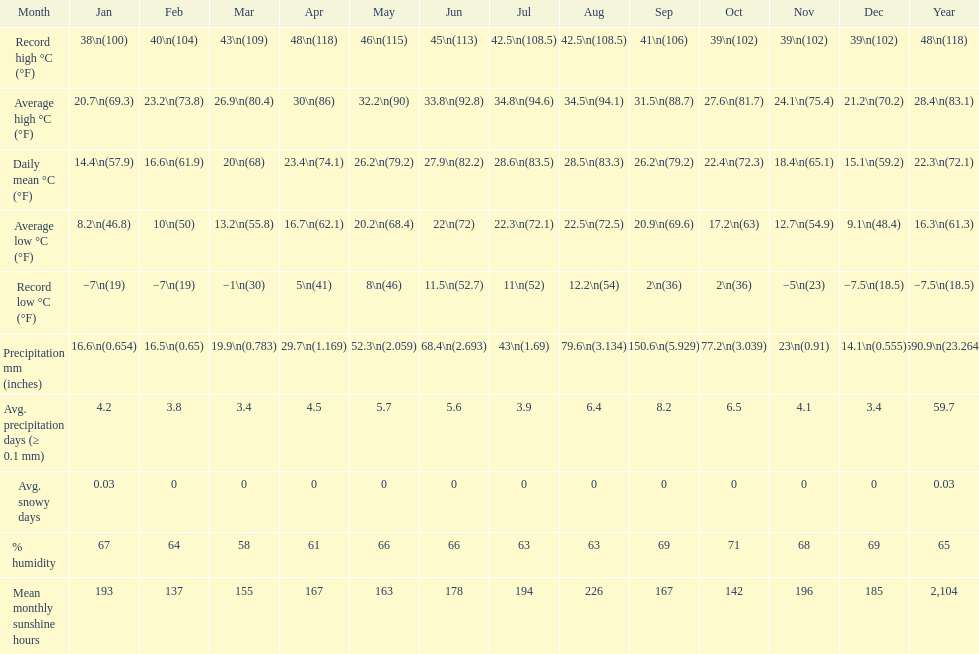Which month had a record high temperature of 100 degrees fahrenheit and also a record low temperature of 19 degrees fahrenheit? January. 